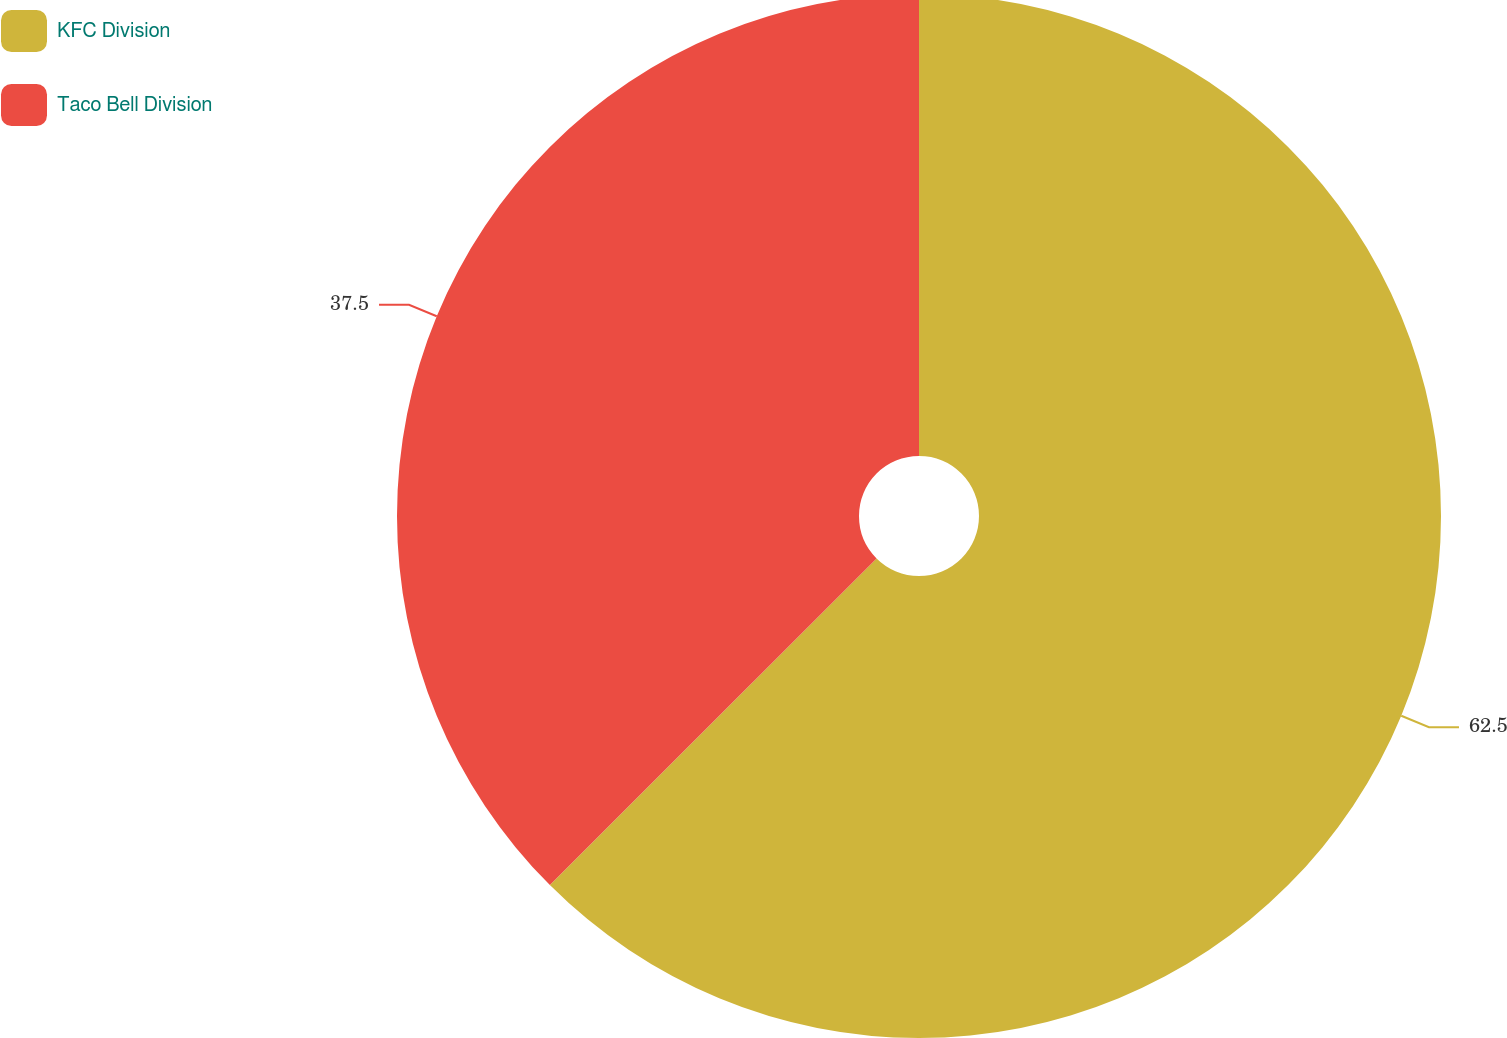Convert chart. <chart><loc_0><loc_0><loc_500><loc_500><pie_chart><fcel>KFC Division<fcel>Taco Bell Division<nl><fcel>62.5%<fcel>37.5%<nl></chart> 